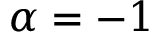<formula> <loc_0><loc_0><loc_500><loc_500>\alpha = - 1</formula> 